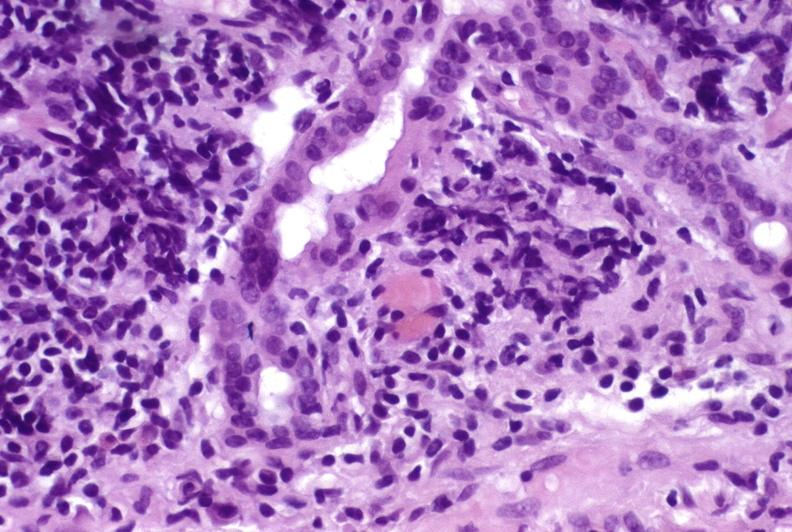s liver present?
Answer the question using a single word or phrase. Yes 